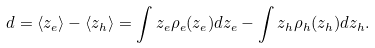Convert formula to latex. <formula><loc_0><loc_0><loc_500><loc_500>d = \langle z _ { e } \rangle - \langle z _ { h } \rangle = \int z _ { e } \rho _ { e } ( z _ { e } ) d z _ { e } - \int z _ { h } \rho _ { h } ( z _ { h } ) d z _ { h } .</formula> 